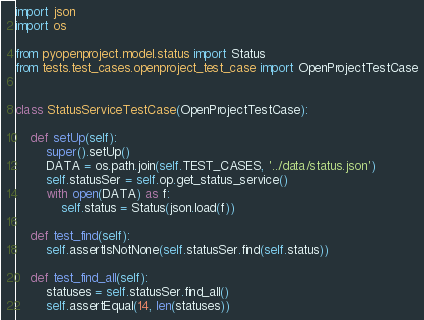Convert code to text. <code><loc_0><loc_0><loc_500><loc_500><_Python_>import json
import os

from pyopenproject.model.status import Status
from tests.test_cases.openproject_test_case import OpenProjectTestCase


class StatusServiceTestCase(OpenProjectTestCase):

    def setUp(self):
        super().setUp()
        DATA = os.path.join(self.TEST_CASES, '../data/status.json')
        self.statusSer = self.op.get_status_service()
        with open(DATA) as f:
            self.status = Status(json.load(f))

    def test_find(self):
        self.assertIsNotNone(self.statusSer.find(self.status))

    def test_find_all(self):
        statuses = self.statusSer.find_all()
        self.assertEqual(14, len(statuses))

</code> 